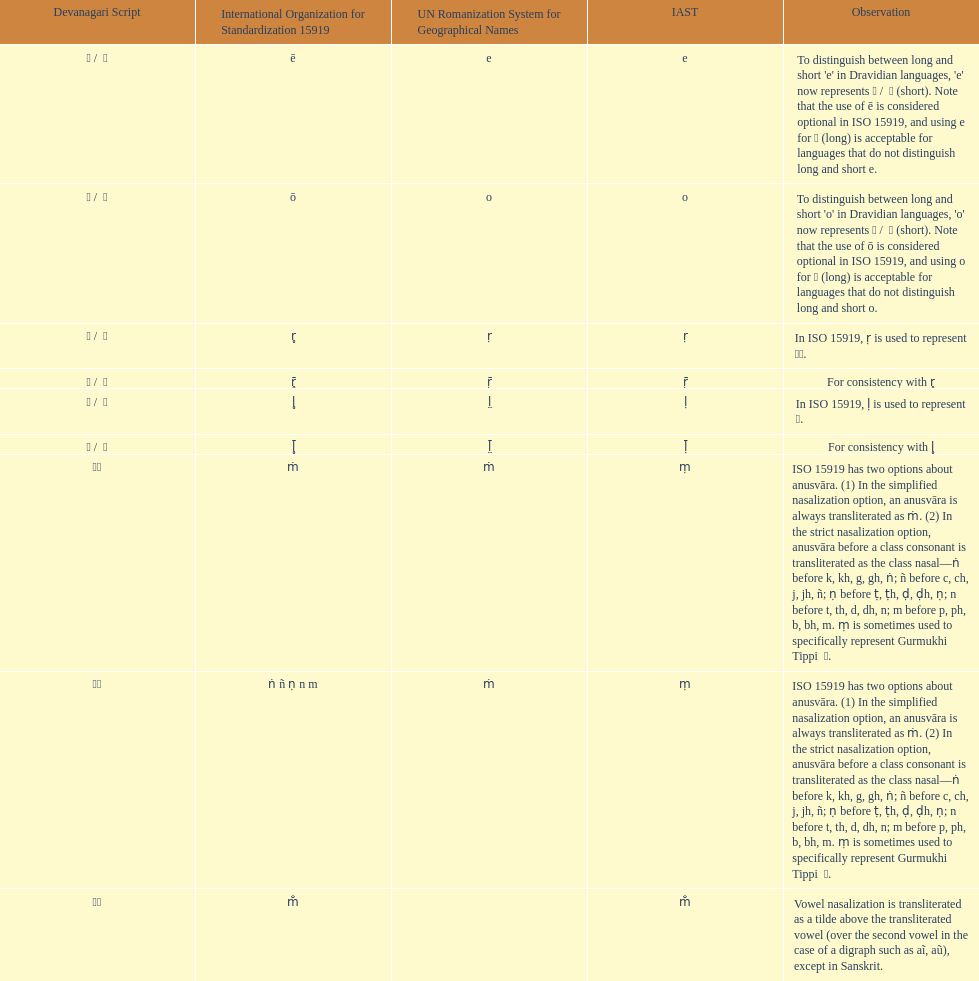What is the total number of translations? 8. Could you parse the entire table as a dict? {'header': ['Devanagari Script', 'International Organization for Standardization 15919', 'UN Romanization System for Geographical Names', 'IAST', 'Observation'], 'rows': [['ए / \xa0े', 'ē', 'e', 'e', "To distinguish between long and short 'e' in Dravidian languages, 'e' now represents ऎ / \xa0ॆ (short). Note that the use of ē is considered optional in ISO 15919, and using e for ए (long) is acceptable for languages that do not distinguish long and short e."], ['ओ / \xa0ो', 'ō', 'o', 'o', "To distinguish between long and short 'o' in Dravidian languages, 'o' now represents ऒ / \xa0ॊ (short). Note that the use of ō is considered optional in ISO 15919, and using o for ओ (long) is acceptable for languages that do not distinguish long and short o."], ['ऋ / \xa0ृ', 'r̥', 'ṛ', 'ṛ', 'In ISO 15919, ṛ is used to represent ड़.'], ['ॠ / \xa0ॄ', 'r̥̄', 'ṝ', 'ṝ', 'For consistency with r̥'], ['ऌ / \xa0ॢ', 'l̥', 'l̤', 'ḷ', 'In ISO 15919, ḷ is used to represent ळ.'], ['ॡ / \xa0ॣ', 'l̥̄', 'l̤̄', 'ḹ', 'For consistency with l̥'], ['◌ं', 'ṁ', 'ṁ', 'ṃ', 'ISO 15919 has two options about anusvāra. (1) In the simplified nasalization option, an anusvāra is always transliterated as ṁ. (2) In the strict nasalization option, anusvāra before a class consonant is transliterated as the class nasal—ṅ before k, kh, g, gh, ṅ; ñ before c, ch, j, jh, ñ; ṇ before ṭ, ṭh, ḍ, ḍh, ṇ; n before t, th, d, dh, n; m before p, ph, b, bh, m. ṃ is sometimes used to specifically represent Gurmukhi Tippi \xa0ੰ.'], ['◌ं', 'ṅ ñ ṇ n m', 'ṁ', 'ṃ', 'ISO 15919 has two options about anusvāra. (1) In the simplified nasalization option, an anusvāra is always transliterated as ṁ. (2) In the strict nasalization option, anusvāra before a class consonant is transliterated as the class nasal—ṅ before k, kh, g, gh, ṅ; ñ before c, ch, j, jh, ñ; ṇ before ṭ, ṭh, ḍ, ḍh, ṇ; n before t, th, d, dh, n; m before p, ph, b, bh, m. ṃ is sometimes used to specifically represent Gurmukhi Tippi \xa0ੰ.'], ['◌ँ', 'm̐', '', 'm̐', 'Vowel nasalization is transliterated as a tilde above the transliterated vowel (over the second vowel in the case of a digraph such as aĩ, aũ), except in Sanskrit.']]} 